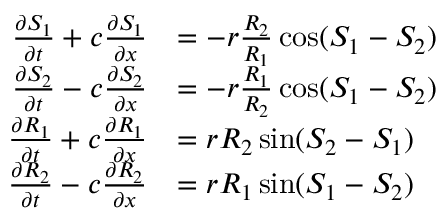<formula> <loc_0><loc_0><loc_500><loc_500>\begin{array} { r l } { \frac { \partial S _ { 1 } } { \partial t } + c \frac { \partial S _ { 1 } } { \partial x } } & { = - r \frac { R _ { 2 } } { R _ { 1 } } \cos ( S _ { 1 } - S _ { 2 } ) } \\ { \frac { \partial S _ { 2 } } { \partial t } - c \frac { \partial S _ { 2 } } { \partial x } } & { = - r \frac { R _ { 1 } } { R _ { 2 } } \cos ( S _ { 1 } - S _ { 2 } ) } \\ { \frac { \partial R _ { 1 } } { \partial t } + c \frac { \partial R _ { 1 } } { \partial x } } & { = r R _ { 2 } \sin ( S _ { 2 } - S _ { 1 } ) } \\ { \frac { \partial R _ { 2 } } { \partial t } - c \frac { \partial R _ { 2 } } { \partial x } } & { = r R _ { 1 } \sin ( S _ { 1 } - S _ { 2 } ) } \end{array}</formula> 